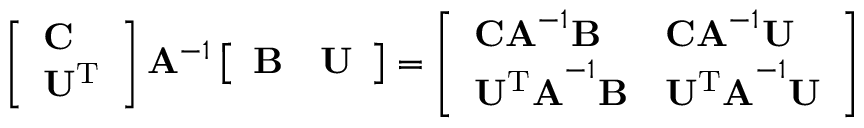<formula> <loc_0><loc_0><loc_500><loc_500>\begin{array} { r } { \left [ \begin{array} { l } { C } \\ { U ^ { T } } \end{array} \right ] A ^ { - 1 } \left [ \begin{array} { l l } { B } & { U } \end{array} \right ] = \left [ \begin{array} { l l } { C A ^ { - 1 } B } & { C A ^ { - 1 } U } \\ { U ^ { T } A ^ { - 1 } B } & { U ^ { T } A ^ { - 1 } U } \end{array} \right ] } \end{array}</formula> 